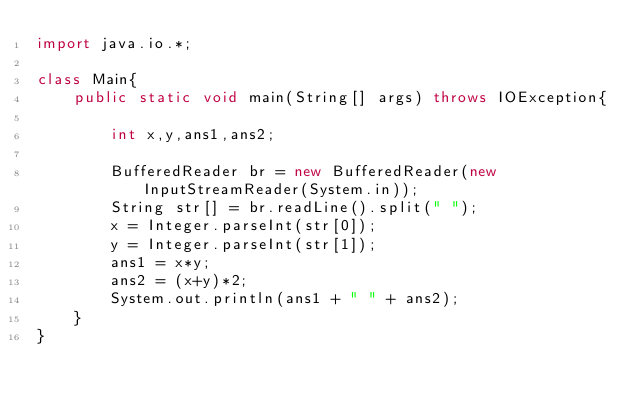Convert code to text. <code><loc_0><loc_0><loc_500><loc_500><_Java_>import java.io.*;

class Main{
	public static void main(String[] args) throws IOException{
	
		int x,y,ans1,ans2;

		BufferedReader br = new BufferedReader(new InputStreamReader(System.in));
		String str[] = br.readLine().split(" ");
		x = Integer.parseInt(str[0]);
		y = Integer.parseInt(str[1]);
		ans1 = x*y;
		ans2 = (x+y)*2;
		System.out.println(ans1 + " " + ans2);
	}
}</code> 